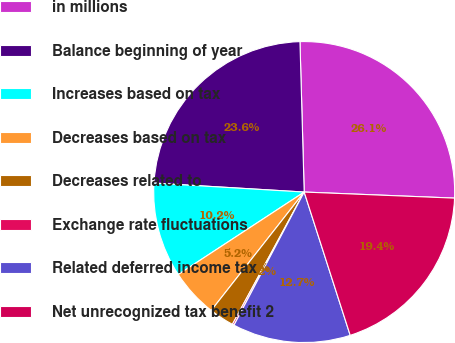Convert chart. <chart><loc_0><loc_0><loc_500><loc_500><pie_chart><fcel>in millions<fcel>Balance beginning of year<fcel>Increases based on tax<fcel>Decreases based on tax<fcel>Decreases related to<fcel>Exchange rate fluctuations<fcel>Related deferred income tax<fcel>Net unrecognized tax benefit 2<nl><fcel>26.09%<fcel>23.6%<fcel>10.18%<fcel>5.18%<fcel>2.68%<fcel>0.19%<fcel>12.67%<fcel>19.41%<nl></chart> 